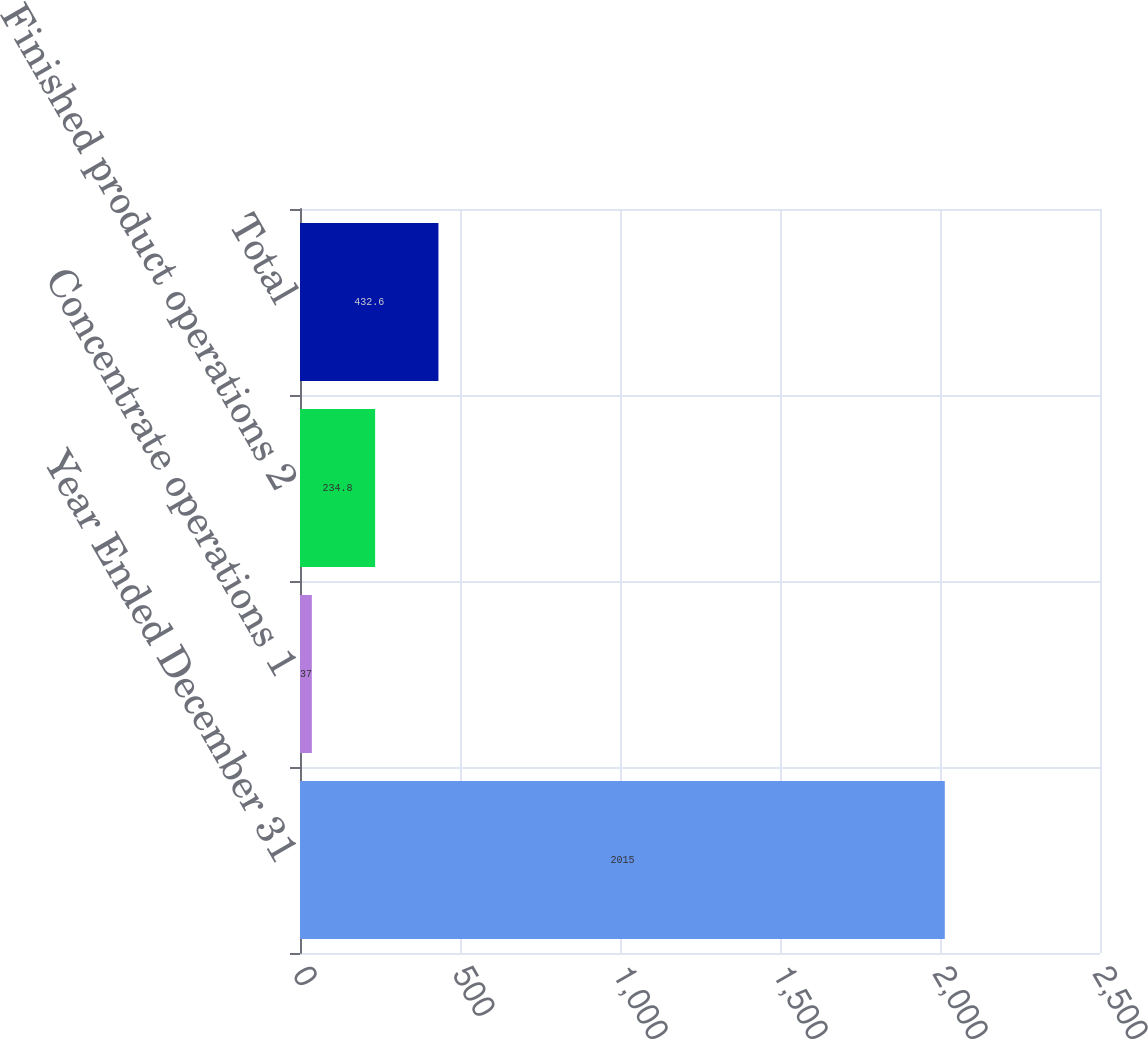<chart> <loc_0><loc_0><loc_500><loc_500><bar_chart><fcel>Year Ended December 31<fcel>Concentrate operations 1<fcel>Finished product operations 2<fcel>Total<nl><fcel>2015<fcel>37<fcel>234.8<fcel>432.6<nl></chart> 